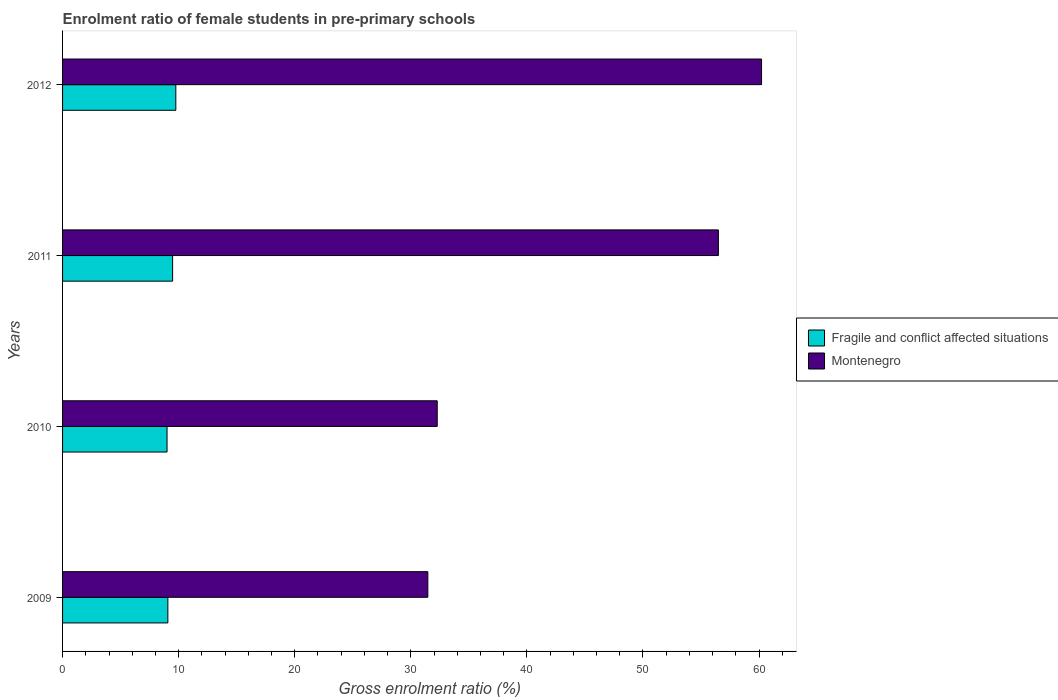How many different coloured bars are there?
Keep it short and to the point. 2. How many groups of bars are there?
Your answer should be compact. 4. Are the number of bars per tick equal to the number of legend labels?
Your response must be concise. Yes. Are the number of bars on each tick of the Y-axis equal?
Your answer should be compact. Yes. In how many cases, is the number of bars for a given year not equal to the number of legend labels?
Offer a terse response. 0. What is the enrolment ratio of female students in pre-primary schools in Fragile and conflict affected situations in 2009?
Provide a short and direct response. 9.07. Across all years, what is the maximum enrolment ratio of female students in pre-primary schools in Montenegro?
Offer a very short reply. 60.22. Across all years, what is the minimum enrolment ratio of female students in pre-primary schools in Montenegro?
Provide a succinct answer. 31.47. In which year was the enrolment ratio of female students in pre-primary schools in Montenegro maximum?
Your answer should be compact. 2012. In which year was the enrolment ratio of female students in pre-primary schools in Fragile and conflict affected situations minimum?
Provide a short and direct response. 2010. What is the total enrolment ratio of female students in pre-primary schools in Montenegro in the graph?
Ensure brevity in your answer.  180.46. What is the difference between the enrolment ratio of female students in pre-primary schools in Montenegro in 2009 and that in 2012?
Your response must be concise. -28.75. What is the difference between the enrolment ratio of female students in pre-primary schools in Montenegro in 2010 and the enrolment ratio of female students in pre-primary schools in Fragile and conflict affected situations in 2012?
Provide a short and direct response. 22.52. What is the average enrolment ratio of female students in pre-primary schools in Fragile and conflict affected situations per year?
Your answer should be very brief. 9.33. In the year 2010, what is the difference between the enrolment ratio of female students in pre-primary schools in Montenegro and enrolment ratio of female students in pre-primary schools in Fragile and conflict affected situations?
Make the answer very short. 23.28. What is the ratio of the enrolment ratio of female students in pre-primary schools in Montenegro in 2009 to that in 2010?
Offer a terse response. 0.97. Is the enrolment ratio of female students in pre-primary schools in Fragile and conflict affected situations in 2009 less than that in 2011?
Keep it short and to the point. Yes. What is the difference between the highest and the second highest enrolment ratio of female students in pre-primary schools in Montenegro?
Offer a terse response. 3.72. What is the difference between the highest and the lowest enrolment ratio of female students in pre-primary schools in Fragile and conflict affected situations?
Give a very brief answer. 0.76. In how many years, is the enrolment ratio of female students in pre-primary schools in Montenegro greater than the average enrolment ratio of female students in pre-primary schools in Montenegro taken over all years?
Offer a very short reply. 2. Is the sum of the enrolment ratio of female students in pre-primary schools in Fragile and conflict affected situations in 2009 and 2010 greater than the maximum enrolment ratio of female students in pre-primary schools in Montenegro across all years?
Ensure brevity in your answer.  No. What does the 1st bar from the top in 2010 represents?
Provide a short and direct response. Montenegro. What does the 1st bar from the bottom in 2012 represents?
Give a very brief answer. Fragile and conflict affected situations. Are all the bars in the graph horizontal?
Give a very brief answer. Yes. How many years are there in the graph?
Make the answer very short. 4. Are the values on the major ticks of X-axis written in scientific E-notation?
Offer a terse response. No. Does the graph contain any zero values?
Give a very brief answer. No. Does the graph contain grids?
Keep it short and to the point. No. How are the legend labels stacked?
Offer a very short reply. Vertical. What is the title of the graph?
Provide a short and direct response. Enrolment ratio of female students in pre-primary schools. Does "Dominican Republic" appear as one of the legend labels in the graph?
Your answer should be very brief. No. What is the label or title of the X-axis?
Provide a succinct answer. Gross enrolment ratio (%). What is the Gross enrolment ratio (%) in Fragile and conflict affected situations in 2009?
Provide a succinct answer. 9.07. What is the Gross enrolment ratio (%) of Montenegro in 2009?
Provide a short and direct response. 31.47. What is the Gross enrolment ratio (%) of Fragile and conflict affected situations in 2010?
Give a very brief answer. 9. What is the Gross enrolment ratio (%) of Montenegro in 2010?
Offer a very short reply. 32.28. What is the Gross enrolment ratio (%) in Fragile and conflict affected situations in 2011?
Give a very brief answer. 9.48. What is the Gross enrolment ratio (%) of Montenegro in 2011?
Make the answer very short. 56.5. What is the Gross enrolment ratio (%) of Fragile and conflict affected situations in 2012?
Your response must be concise. 9.76. What is the Gross enrolment ratio (%) in Montenegro in 2012?
Your answer should be very brief. 60.22. Across all years, what is the maximum Gross enrolment ratio (%) in Fragile and conflict affected situations?
Your answer should be very brief. 9.76. Across all years, what is the maximum Gross enrolment ratio (%) in Montenegro?
Your response must be concise. 60.22. Across all years, what is the minimum Gross enrolment ratio (%) of Fragile and conflict affected situations?
Your response must be concise. 9. Across all years, what is the minimum Gross enrolment ratio (%) in Montenegro?
Your response must be concise. 31.47. What is the total Gross enrolment ratio (%) of Fragile and conflict affected situations in the graph?
Make the answer very short. 37.31. What is the total Gross enrolment ratio (%) in Montenegro in the graph?
Keep it short and to the point. 180.46. What is the difference between the Gross enrolment ratio (%) in Fragile and conflict affected situations in 2009 and that in 2010?
Offer a very short reply. 0.07. What is the difference between the Gross enrolment ratio (%) in Montenegro in 2009 and that in 2010?
Offer a terse response. -0.81. What is the difference between the Gross enrolment ratio (%) of Fragile and conflict affected situations in 2009 and that in 2011?
Offer a terse response. -0.41. What is the difference between the Gross enrolment ratio (%) in Montenegro in 2009 and that in 2011?
Your answer should be very brief. -25.03. What is the difference between the Gross enrolment ratio (%) in Fragile and conflict affected situations in 2009 and that in 2012?
Provide a short and direct response. -0.69. What is the difference between the Gross enrolment ratio (%) in Montenegro in 2009 and that in 2012?
Ensure brevity in your answer.  -28.75. What is the difference between the Gross enrolment ratio (%) in Fragile and conflict affected situations in 2010 and that in 2011?
Your answer should be very brief. -0.48. What is the difference between the Gross enrolment ratio (%) in Montenegro in 2010 and that in 2011?
Ensure brevity in your answer.  -24.22. What is the difference between the Gross enrolment ratio (%) of Fragile and conflict affected situations in 2010 and that in 2012?
Keep it short and to the point. -0.76. What is the difference between the Gross enrolment ratio (%) in Montenegro in 2010 and that in 2012?
Offer a very short reply. -27.94. What is the difference between the Gross enrolment ratio (%) in Fragile and conflict affected situations in 2011 and that in 2012?
Offer a very short reply. -0.28. What is the difference between the Gross enrolment ratio (%) in Montenegro in 2011 and that in 2012?
Provide a succinct answer. -3.72. What is the difference between the Gross enrolment ratio (%) of Fragile and conflict affected situations in 2009 and the Gross enrolment ratio (%) of Montenegro in 2010?
Make the answer very short. -23.2. What is the difference between the Gross enrolment ratio (%) in Fragile and conflict affected situations in 2009 and the Gross enrolment ratio (%) in Montenegro in 2011?
Make the answer very short. -47.43. What is the difference between the Gross enrolment ratio (%) in Fragile and conflict affected situations in 2009 and the Gross enrolment ratio (%) in Montenegro in 2012?
Provide a short and direct response. -51.15. What is the difference between the Gross enrolment ratio (%) in Fragile and conflict affected situations in 2010 and the Gross enrolment ratio (%) in Montenegro in 2011?
Ensure brevity in your answer.  -47.5. What is the difference between the Gross enrolment ratio (%) in Fragile and conflict affected situations in 2010 and the Gross enrolment ratio (%) in Montenegro in 2012?
Offer a terse response. -51.22. What is the difference between the Gross enrolment ratio (%) in Fragile and conflict affected situations in 2011 and the Gross enrolment ratio (%) in Montenegro in 2012?
Offer a terse response. -50.74. What is the average Gross enrolment ratio (%) in Fragile and conflict affected situations per year?
Your answer should be very brief. 9.33. What is the average Gross enrolment ratio (%) in Montenegro per year?
Your answer should be very brief. 45.11. In the year 2009, what is the difference between the Gross enrolment ratio (%) in Fragile and conflict affected situations and Gross enrolment ratio (%) in Montenegro?
Offer a terse response. -22.4. In the year 2010, what is the difference between the Gross enrolment ratio (%) of Fragile and conflict affected situations and Gross enrolment ratio (%) of Montenegro?
Offer a very short reply. -23.27. In the year 2011, what is the difference between the Gross enrolment ratio (%) in Fragile and conflict affected situations and Gross enrolment ratio (%) in Montenegro?
Keep it short and to the point. -47.02. In the year 2012, what is the difference between the Gross enrolment ratio (%) of Fragile and conflict affected situations and Gross enrolment ratio (%) of Montenegro?
Ensure brevity in your answer.  -50.46. What is the ratio of the Gross enrolment ratio (%) in Montenegro in 2009 to that in 2010?
Ensure brevity in your answer.  0.97. What is the ratio of the Gross enrolment ratio (%) in Fragile and conflict affected situations in 2009 to that in 2011?
Provide a short and direct response. 0.96. What is the ratio of the Gross enrolment ratio (%) in Montenegro in 2009 to that in 2011?
Your answer should be compact. 0.56. What is the ratio of the Gross enrolment ratio (%) in Fragile and conflict affected situations in 2009 to that in 2012?
Provide a succinct answer. 0.93. What is the ratio of the Gross enrolment ratio (%) in Montenegro in 2009 to that in 2012?
Make the answer very short. 0.52. What is the ratio of the Gross enrolment ratio (%) of Fragile and conflict affected situations in 2010 to that in 2011?
Your answer should be compact. 0.95. What is the ratio of the Gross enrolment ratio (%) of Montenegro in 2010 to that in 2011?
Offer a very short reply. 0.57. What is the ratio of the Gross enrolment ratio (%) of Fragile and conflict affected situations in 2010 to that in 2012?
Your answer should be very brief. 0.92. What is the ratio of the Gross enrolment ratio (%) of Montenegro in 2010 to that in 2012?
Make the answer very short. 0.54. What is the ratio of the Gross enrolment ratio (%) of Fragile and conflict affected situations in 2011 to that in 2012?
Offer a very short reply. 0.97. What is the ratio of the Gross enrolment ratio (%) in Montenegro in 2011 to that in 2012?
Your answer should be compact. 0.94. What is the difference between the highest and the second highest Gross enrolment ratio (%) in Fragile and conflict affected situations?
Your response must be concise. 0.28. What is the difference between the highest and the second highest Gross enrolment ratio (%) in Montenegro?
Make the answer very short. 3.72. What is the difference between the highest and the lowest Gross enrolment ratio (%) of Fragile and conflict affected situations?
Offer a very short reply. 0.76. What is the difference between the highest and the lowest Gross enrolment ratio (%) in Montenegro?
Provide a short and direct response. 28.75. 